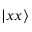<formula> <loc_0><loc_0><loc_500><loc_500>| x x \rangle</formula> 